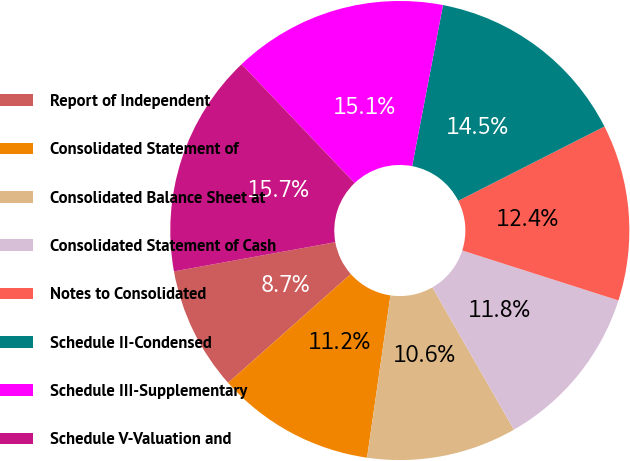<chart> <loc_0><loc_0><loc_500><loc_500><pie_chart><fcel>Report of Independent<fcel>Consolidated Statement of<fcel>Consolidated Balance Sheet at<fcel>Consolidated Statement of Cash<fcel>Notes to Consolidated<fcel>Schedule II-Condensed<fcel>Schedule III-Supplementary<fcel>Schedule V-Valuation and<nl><fcel>8.7%<fcel>11.17%<fcel>10.56%<fcel>11.79%<fcel>12.41%<fcel>14.5%<fcel>15.12%<fcel>15.74%<nl></chart> 